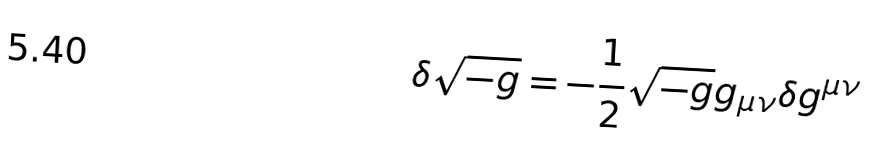<formula> <loc_0><loc_0><loc_500><loc_500>\delta { \sqrt { - g } } = - { \frac { 1 } { 2 } } { \sqrt { - g } } g _ { \mu \nu } \delta g ^ { \mu \nu }</formula> 